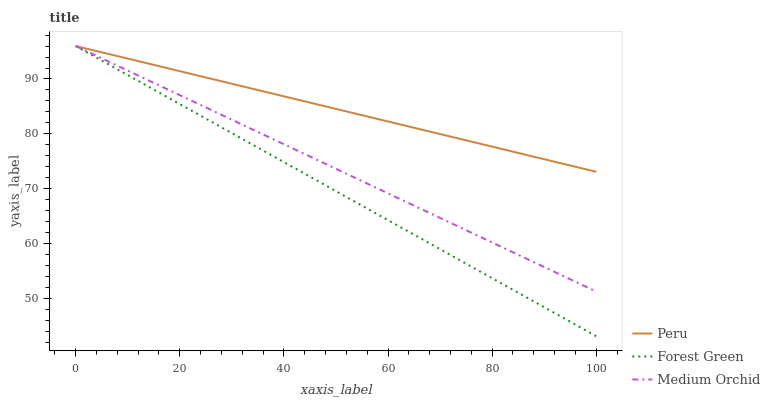Does Forest Green have the minimum area under the curve?
Answer yes or no. Yes. Does Peru have the maximum area under the curve?
Answer yes or no. Yes. Does Medium Orchid have the minimum area under the curve?
Answer yes or no. No. Does Medium Orchid have the maximum area under the curve?
Answer yes or no. No. Is Peru the smoothest?
Answer yes or no. Yes. Is Forest Green the roughest?
Answer yes or no. Yes. Is Medium Orchid the smoothest?
Answer yes or no. No. Is Medium Orchid the roughest?
Answer yes or no. No. Does Forest Green have the lowest value?
Answer yes or no. Yes. Does Medium Orchid have the lowest value?
Answer yes or no. No. Does Peru have the highest value?
Answer yes or no. Yes. Does Forest Green intersect Medium Orchid?
Answer yes or no. Yes. Is Forest Green less than Medium Orchid?
Answer yes or no. No. Is Forest Green greater than Medium Orchid?
Answer yes or no. No. 